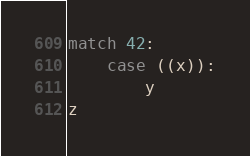<code> <loc_0><loc_0><loc_500><loc_500><_Python_>match 42:
    case ((x)):
        y
z</code> 